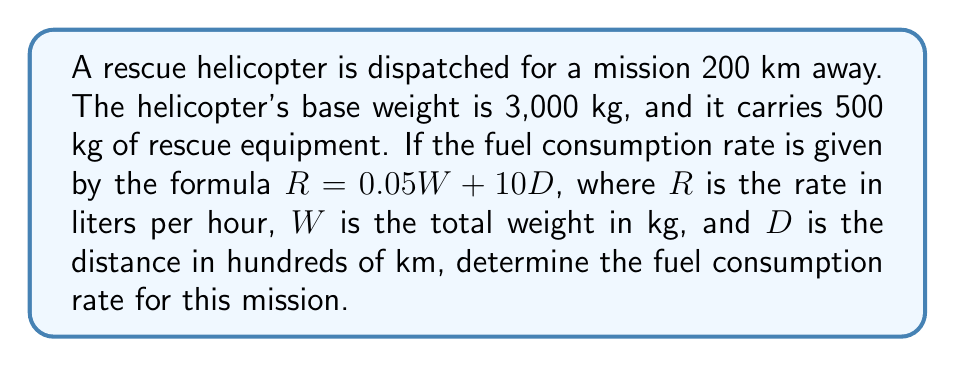Can you answer this question? To solve this problem, we'll follow these steps:

1. Calculate the total weight of the helicopter:
   $W = \text{Base weight} + \text{Equipment weight}$
   $W = 3000 \text{ kg} + 500 \text{ kg} = 3500 \text{ kg}$

2. Convert the distance to hundreds of km:
   $D = 200 \text{ km} \div 100 = 2$

3. Apply the given formula:
   $R = 0.05W + 10D$
   
   Substitute the values:
   $R = 0.05(3500) + 10(2)$

4. Calculate:
   $R = 175 + 20 = 195$

Therefore, the fuel consumption rate for this mission is 195 liters per hour.
Answer: 195 L/h 